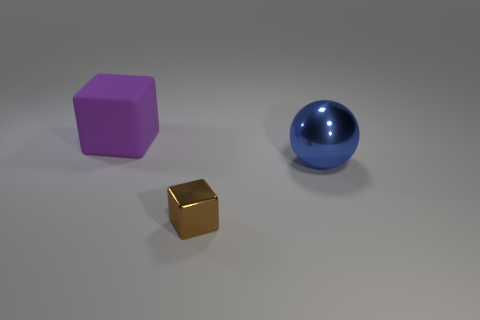Does the blue thing have the same material as the object to the left of the tiny object?
Your answer should be compact. No. What is the blue sphere made of?
Offer a very short reply. Metal. There is a thing left of the thing that is in front of the big object in front of the big purple rubber object; what is its material?
Provide a succinct answer. Rubber. Is there any other thing that has the same shape as the large blue thing?
Your answer should be very brief. No. What is the color of the shiny thing that is to the left of the metal object on the right side of the tiny brown metal cube?
Your answer should be compact. Brown. What number of small rubber objects are there?
Your response must be concise. 0. What number of rubber things are either brown spheres or small objects?
Provide a succinct answer. 0. There is a big thing that is behind the metallic thing that is behind the brown object; what is it made of?
Give a very brief answer. Rubber. The blue metal ball has what size?
Provide a succinct answer. Large. How many metal balls are the same size as the matte thing?
Your answer should be compact. 1. 